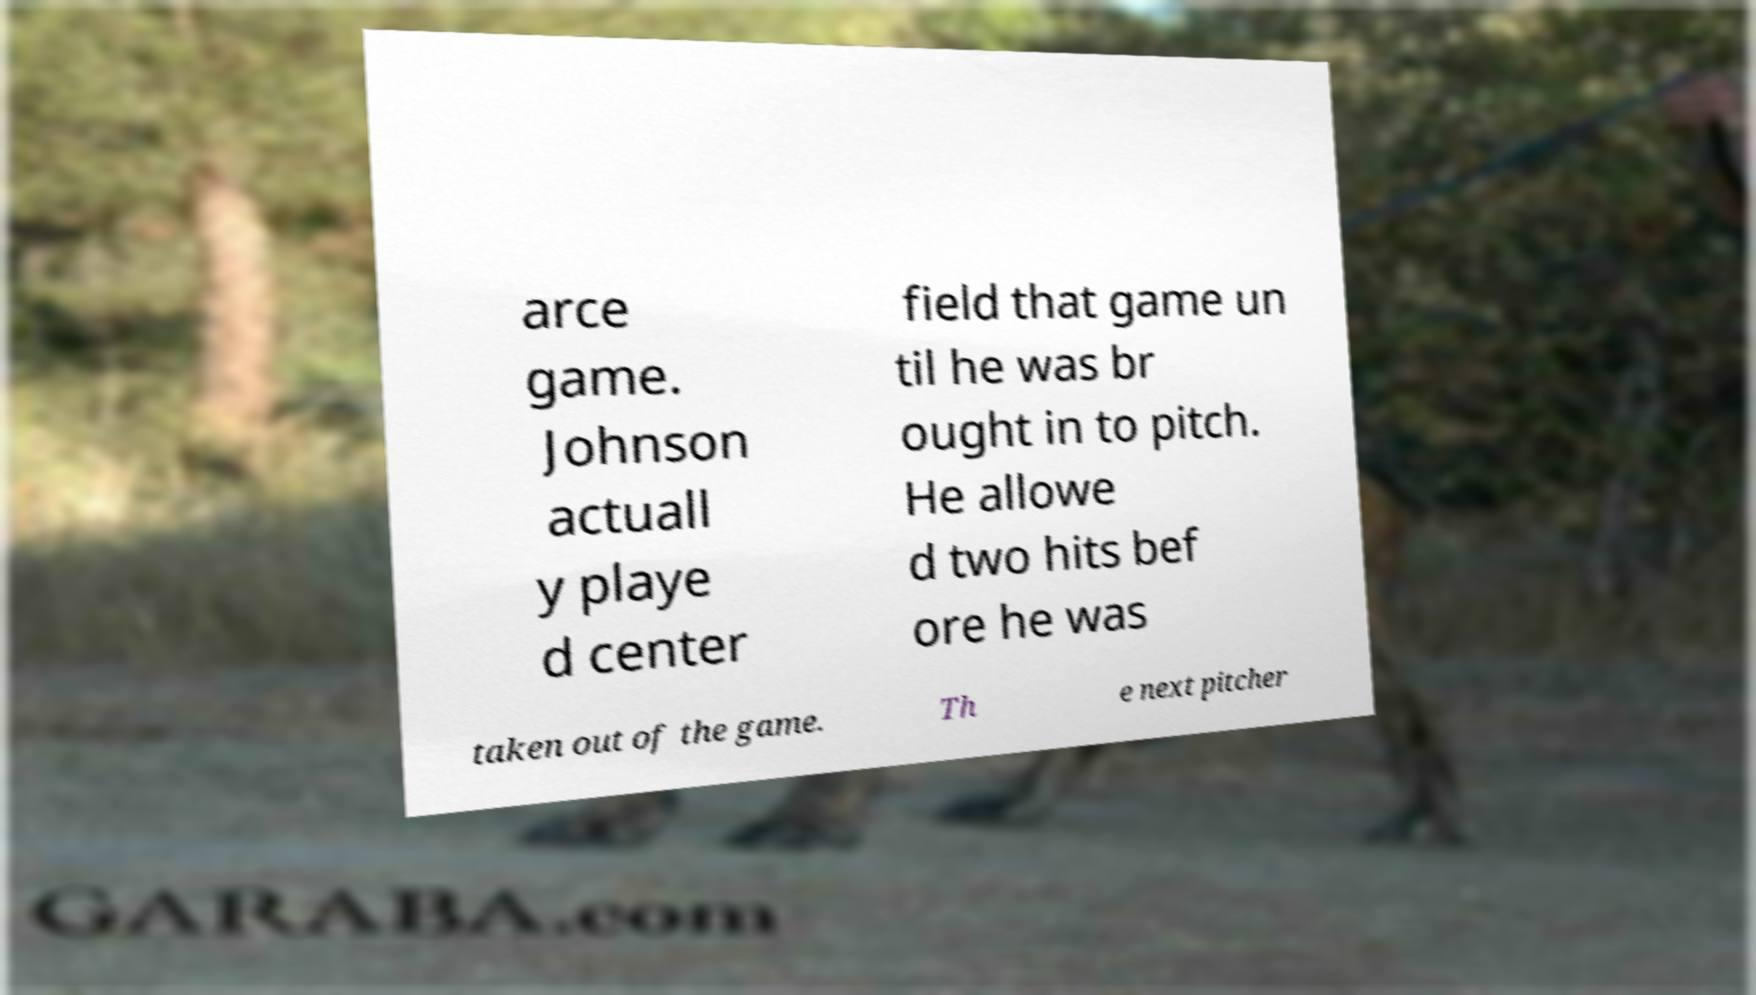Could you assist in decoding the text presented in this image and type it out clearly? arce game. Johnson actuall y playe d center field that game un til he was br ought in to pitch. He allowe d two hits bef ore he was taken out of the game. Th e next pitcher 